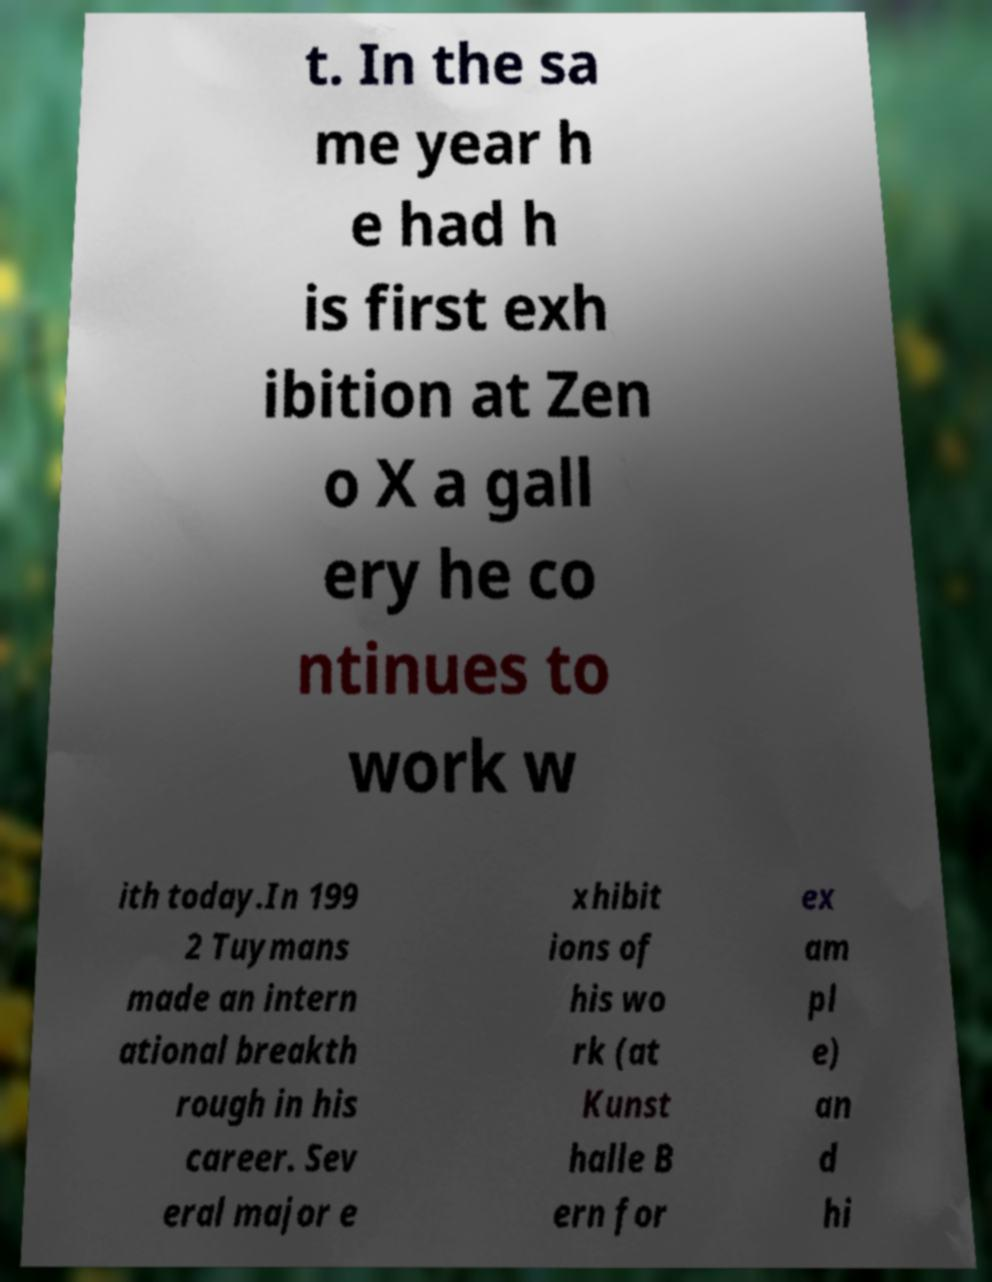Could you assist in decoding the text presented in this image and type it out clearly? t. In the sa me year h e had h is first exh ibition at Zen o X a gall ery he co ntinues to work w ith today.In 199 2 Tuymans made an intern ational breakth rough in his career. Sev eral major e xhibit ions of his wo rk (at Kunst halle B ern for ex am pl e) an d hi 